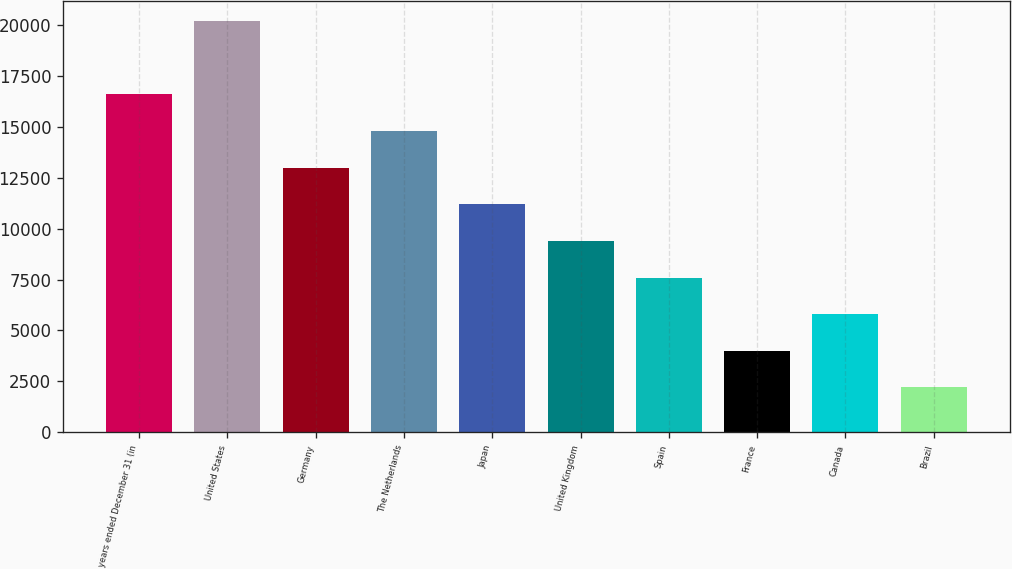Convert chart. <chart><loc_0><loc_0><loc_500><loc_500><bar_chart><fcel>years ended December 31 (in<fcel>United States<fcel>Germany<fcel>The Netherlands<fcel>Japan<fcel>United Kingdom<fcel>Spain<fcel>France<fcel>Canada<fcel>Brazil<nl><fcel>16582.8<fcel>20177.2<fcel>12988.4<fcel>14785.6<fcel>11191.2<fcel>9394<fcel>7596.8<fcel>4002.4<fcel>5799.6<fcel>2205.2<nl></chart> 